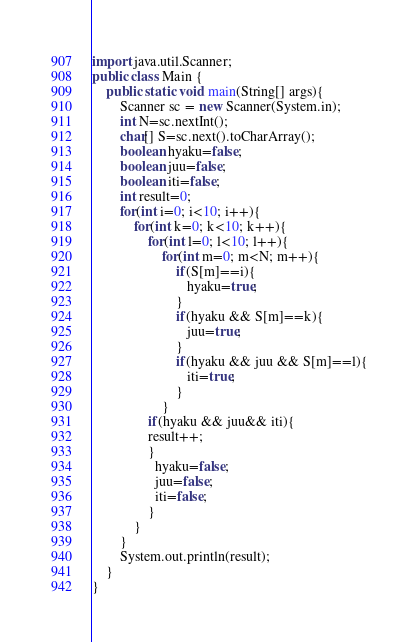<code> <loc_0><loc_0><loc_500><loc_500><_Java_>import java.util.Scanner;
public class Main {
	public static void main(String[] args){
		Scanner sc = new Scanner(System.in);
		int N=sc.nextInt();
		char[] S=sc.next().toCharArray();
        boolean hyaku=false;
        boolean juu=false;
        boolean iti=false;
        int result=0;
        for(int i=0; i<10; i++){
            for(int k=0; k<10; k++){
                for(int l=0; l<10; l++){
                    for(int m=0; m<N; m++){
                        if(S[m]==i){
                           hyaku=true;
                        }
                        if(hyaku && S[m]==k){
                           juu=true;
                        }
                        if(hyaku && juu && S[m]==l){
                           iti=true;
                        }
                    }
                if(hyaku && juu&& iti){
                result++;
                }
                  hyaku=false;
                  juu=false;
                  iti=false;
                }
            }
        }
		System.out.println(result);
	}
}
</code> 